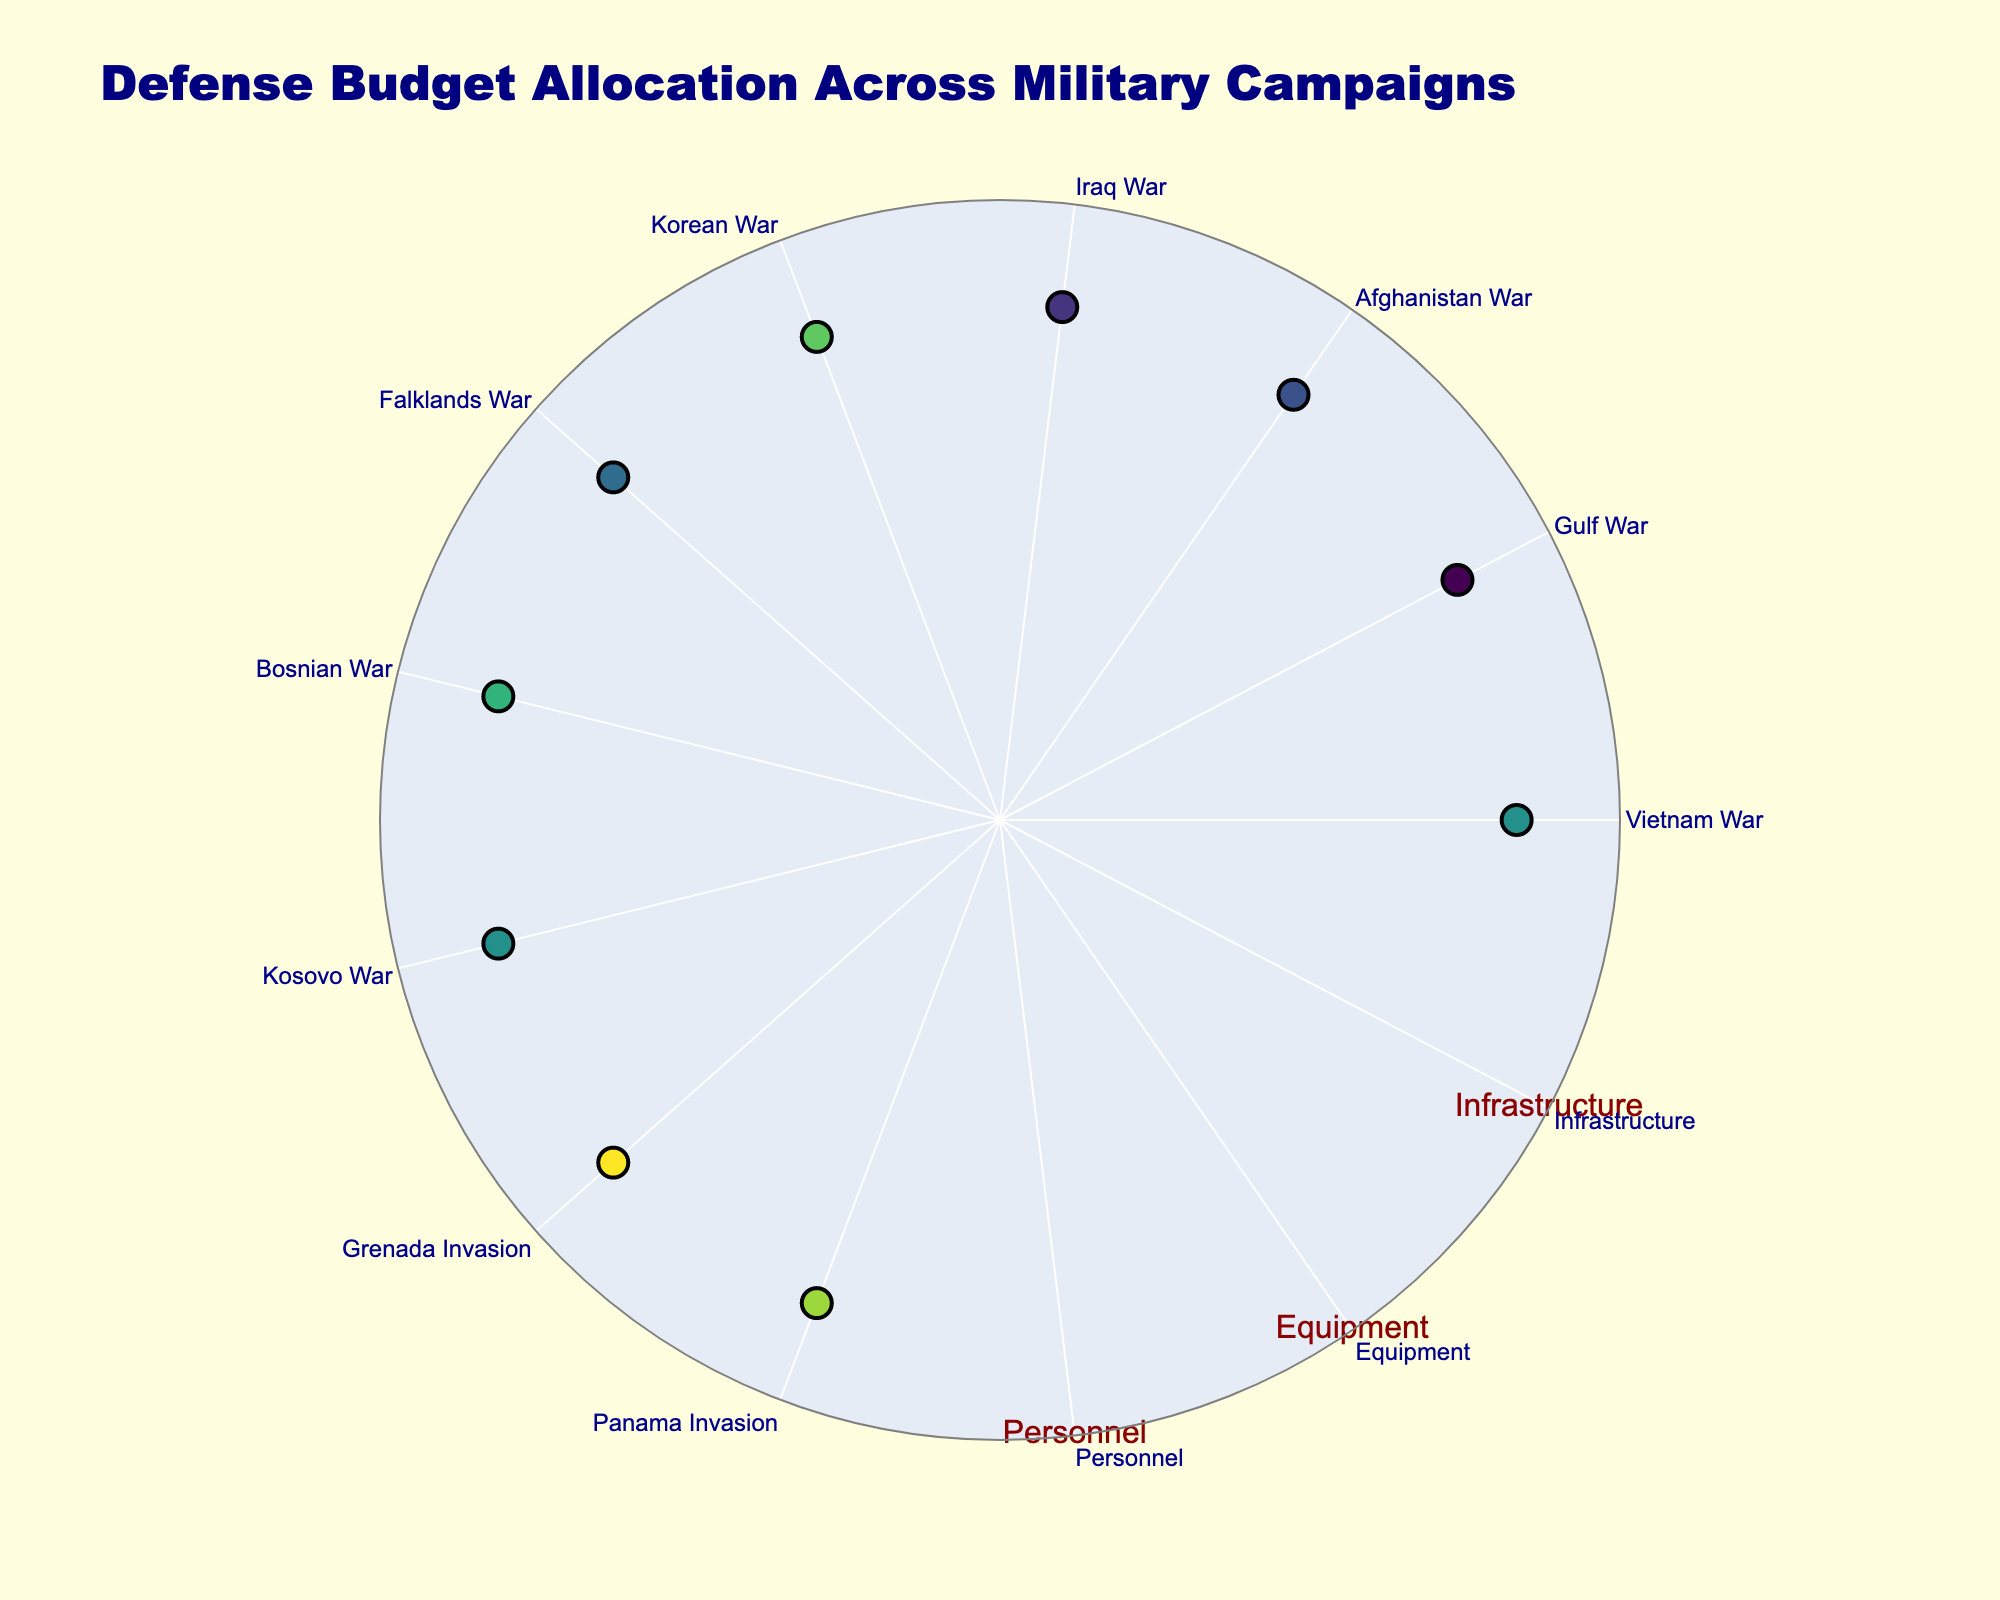Which campaign has the highest allocation to personnel? To determine the campaign with the highest allocation to personnel, we need to refer to the plot's markers' textual information. The "Grenada Invasion" allocates 55% to personnel, which is the highest percentage among all campaigns.
Answer: Grenada Invasion How many campaigns have an equal infrastructure allocation? We observe from the plot that each marker has its textual information. All campaigns, except "Kosovo War," "Grenada Invasion," and "Panama Invasion," allocate 15% to infrastructure. In total, 7 campaigns have an equal allocation to infrastructure.
Answer: 7 What is the combined percentage allocation to equipment for the Vietnam War and the Gulf War? We find the equipment allocation for both wars from the plot details. Vietnam War allocates 40% and Gulf War allocates 50% to equipment, resulting in a combined allocation of 40 + 50 = 90%.
Answer: 90% Which two campaigns have the same allocation percentages for equipment and infrastructure but differ in personnel? By reviewing the plots and their textual data, both "Afghanistan War" and "Iraq War" allocate 45% to equipment and 15% to infrastructure but differ in personnel with 40% and 38%, respectively.
Answer: Afghanistan War and Iraq War How does the personnel allocation compare between the Korean War and the Bosnian War? Referring to the plot, the Korean War allocates 50% and Bosnian War allocates 48% to personnel. The Korean War has a higher allocation to personnel by 2%.
Answer: Korean War allocates 2% more What percent of the campaigns allocate more than 40% to equipment? Observing the plot, the campaigns that allocate more than 40% to equipment are the Gulf War, Afghanistan War, Iraq War, Falklands War, and Kosovo War (5 in total). There are 10 campaigns overall. Hence, the percent is (5/10)*100 = 50%.
Answer: 50% What is the average allocation to equipment across all campaigns? Sum the equipment allocations (40 + 50 + 45 + 47 + 35 + 43 + 37 + 42 + 35 + 38 = 412). Divide by the number of campaigns (10) to get the average: 412/10 = 41.2%.
Answer: 41.2% Which campaign has the lowest total allocation to personnel and infrastructure combined? To find the lowest combined personnel and infrastructure allocation, add these percentages for each campaign and compare. "Grenada Invasion" and "Panama Invasion" both sum to 55% (Personnel: 55 + Infrastructure: 10), which is the lowest total.
Answer: Grenada Invasion and Panama Invasion 